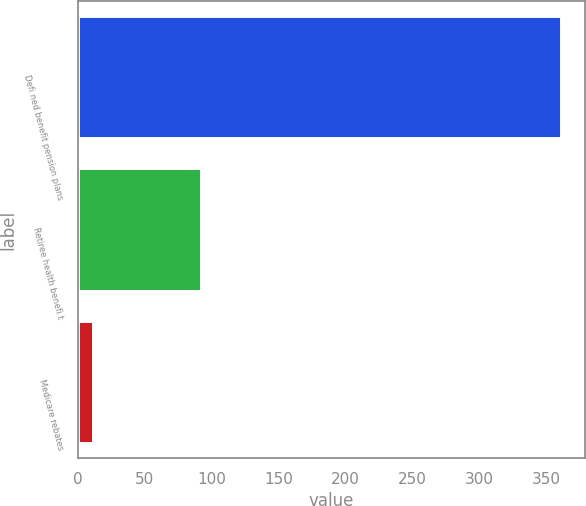<chart> <loc_0><loc_0><loc_500><loc_500><bar_chart><fcel>Defi ned benefit pension plans<fcel>Retiree health benefi t<fcel>Medicare rebates<nl><fcel>360.5<fcel>91.7<fcel>11.6<nl></chart> 